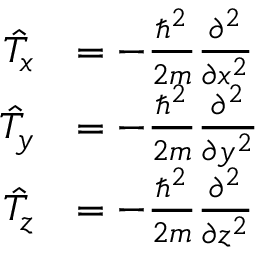Convert formula to latex. <formula><loc_0><loc_0><loc_500><loc_500>{ \begin{array} { r l } { { \hat { T } } _ { x } } & { = - { \frac { \hbar { ^ } { 2 } } { 2 m } } { \frac { \partial ^ { 2 } } { \partial x ^ { 2 } } } } \\ { { \hat { T } } _ { y } } & { = - { \frac { \hbar { ^ } { 2 } } { 2 m } } { \frac { \partial ^ { 2 } } { \partial y ^ { 2 } } } } \\ { { \hat { T } } _ { z } } & { = - { \frac { \hbar { ^ } { 2 } } { 2 m } } { \frac { \partial ^ { 2 } } { \partial z ^ { 2 } } } } \end{array} }</formula> 